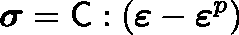Convert formula to latex. <formula><loc_0><loc_0><loc_500><loc_500>{ \sigma } = { C } \colon ( { \varepsilon } - { \varepsilon } ^ { p } )</formula> 